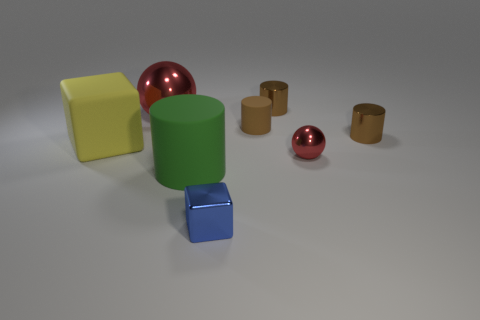How many red balls must be subtracted to get 1 red balls? 1 Subtract all gray cubes. How many brown cylinders are left? 3 Subtract 1 cylinders. How many cylinders are left? 3 Add 1 tiny brown shiny cylinders. How many objects exist? 9 Subtract all blocks. How many objects are left? 6 Subtract 1 green cylinders. How many objects are left? 7 Subtract all small green matte balls. Subtract all tiny red spheres. How many objects are left? 7 Add 2 big red spheres. How many big red spheres are left? 3 Add 6 tiny rubber cylinders. How many tiny rubber cylinders exist? 7 